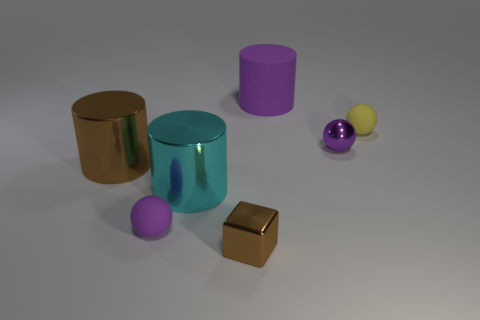What is the color of the small metal object behind the small cube?
Your response must be concise. Purple. Is there anything else of the same color as the small metal cube?
Provide a succinct answer. Yes. Does the yellow rubber object have the same size as the cube?
Ensure brevity in your answer.  Yes. What is the size of the purple thing that is right of the brown cube and in front of the big rubber object?
Make the answer very short. Small. How many large balls are made of the same material as the brown cylinder?
Offer a terse response. 0. There is a big metallic object that is the same color as the small metallic cube; what is its shape?
Provide a short and direct response. Cylinder. The cube is what color?
Offer a very short reply. Brown. There is a small purple thing that is right of the cyan cylinder; is its shape the same as the yellow matte thing?
Offer a terse response. Yes. How many objects are purple shiny objects that are on the right side of the purple rubber ball or small purple rubber objects?
Offer a very short reply. 2. Are there any purple rubber objects of the same shape as the big cyan shiny object?
Provide a short and direct response. Yes. 